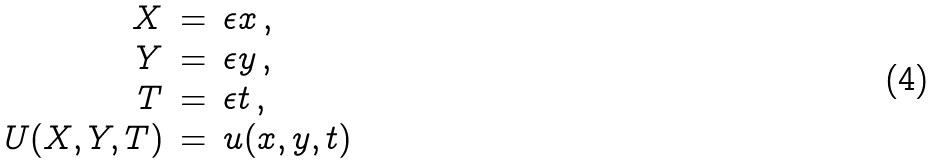Convert formula to latex. <formula><loc_0><loc_0><loc_500><loc_500>\begin{array} { r c l } X & = & \epsilon x \, , \\ Y & = & \epsilon y \, , \\ T & = & \epsilon t \, , \\ U ( X , Y , T ) & = & u ( x , y , t ) \end{array}</formula> 